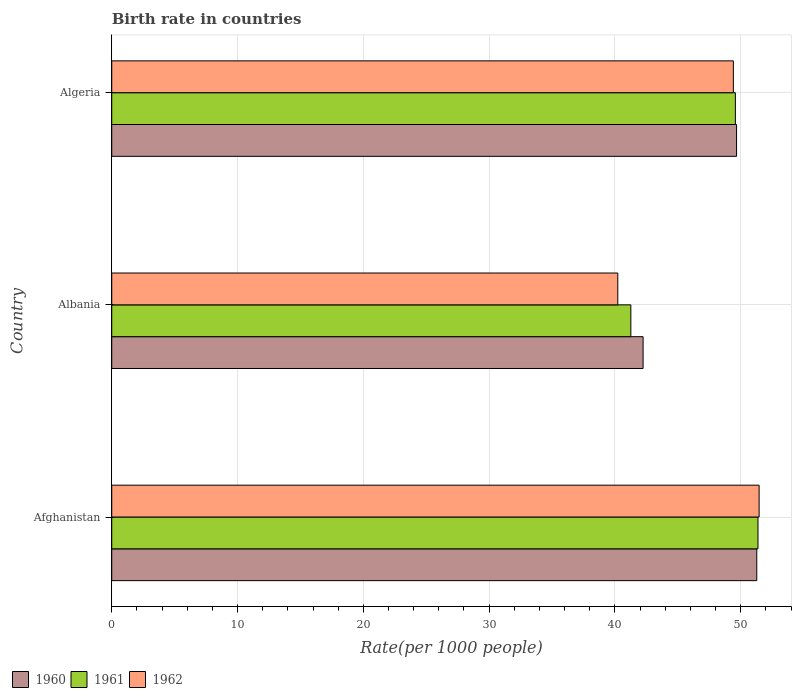How many different coloured bars are there?
Provide a succinct answer. 3. Are the number of bars per tick equal to the number of legend labels?
Offer a terse response. Yes. What is the label of the 1st group of bars from the top?
Make the answer very short. Algeria. In how many cases, is the number of bars for a given country not equal to the number of legend labels?
Your answer should be very brief. 0. What is the birth rate in 1961 in Albania?
Offer a terse response. 41.27. Across all countries, what is the maximum birth rate in 1961?
Your answer should be very brief. 51.37. Across all countries, what is the minimum birth rate in 1961?
Your answer should be compact. 41.27. In which country was the birth rate in 1962 maximum?
Give a very brief answer. Afghanistan. In which country was the birth rate in 1962 minimum?
Keep it short and to the point. Albania. What is the total birth rate in 1962 in the graph?
Your response must be concise. 141.11. What is the difference between the birth rate in 1962 in Afghanistan and that in Albania?
Ensure brevity in your answer.  11.23. What is the difference between the birth rate in 1960 in Algeria and the birth rate in 1961 in Afghanistan?
Offer a terse response. -1.7. What is the average birth rate in 1961 per country?
Ensure brevity in your answer.  47.41. What is the difference between the birth rate in 1961 and birth rate in 1962 in Algeria?
Offer a terse response. 0.16. In how many countries, is the birth rate in 1962 greater than 16 ?
Provide a short and direct response. 3. What is the ratio of the birth rate in 1960 in Albania to that in Algeria?
Your answer should be very brief. 0.85. Is the birth rate in 1962 in Afghanistan less than that in Algeria?
Your answer should be compact. No. What is the difference between the highest and the second highest birth rate in 1960?
Provide a succinct answer. 1.6. What is the difference between the highest and the lowest birth rate in 1961?
Give a very brief answer. 10.11. Is the sum of the birth rate in 1962 in Afghanistan and Algeria greater than the maximum birth rate in 1961 across all countries?
Offer a very short reply. Yes. How many bars are there?
Provide a succinct answer. 9. Are all the bars in the graph horizontal?
Ensure brevity in your answer.  Yes. How many countries are there in the graph?
Keep it short and to the point. 3. Are the values on the major ticks of X-axis written in scientific E-notation?
Make the answer very short. No. Does the graph contain grids?
Your answer should be very brief. Yes. Where does the legend appear in the graph?
Your answer should be very brief. Bottom left. How many legend labels are there?
Provide a succinct answer. 3. What is the title of the graph?
Your answer should be very brief. Birth rate in countries. What is the label or title of the X-axis?
Your response must be concise. Rate(per 1000 people). What is the label or title of the Y-axis?
Ensure brevity in your answer.  Country. What is the Rate(per 1000 people) of 1960 in Afghanistan?
Your answer should be very brief. 51.28. What is the Rate(per 1000 people) in 1961 in Afghanistan?
Give a very brief answer. 51.37. What is the Rate(per 1000 people) in 1962 in Afghanistan?
Offer a terse response. 51.46. What is the Rate(per 1000 people) in 1960 in Albania?
Your answer should be compact. 42.24. What is the Rate(per 1000 people) of 1961 in Albania?
Keep it short and to the point. 41.27. What is the Rate(per 1000 people) of 1962 in Albania?
Provide a succinct answer. 40.23. What is the Rate(per 1000 people) in 1960 in Algeria?
Give a very brief answer. 49.67. What is the Rate(per 1000 people) in 1961 in Algeria?
Your response must be concise. 49.58. What is the Rate(per 1000 people) in 1962 in Algeria?
Provide a short and direct response. 49.42. Across all countries, what is the maximum Rate(per 1000 people) in 1960?
Your response must be concise. 51.28. Across all countries, what is the maximum Rate(per 1000 people) of 1961?
Your answer should be very brief. 51.37. Across all countries, what is the maximum Rate(per 1000 people) of 1962?
Make the answer very short. 51.46. Across all countries, what is the minimum Rate(per 1000 people) in 1960?
Provide a short and direct response. 42.24. Across all countries, what is the minimum Rate(per 1000 people) of 1961?
Your answer should be very brief. 41.27. Across all countries, what is the minimum Rate(per 1000 people) in 1962?
Keep it short and to the point. 40.23. What is the total Rate(per 1000 people) of 1960 in the graph?
Your response must be concise. 143.19. What is the total Rate(per 1000 people) of 1961 in the graph?
Provide a short and direct response. 142.22. What is the total Rate(per 1000 people) in 1962 in the graph?
Provide a short and direct response. 141.11. What is the difference between the Rate(per 1000 people) in 1960 in Afghanistan and that in Albania?
Provide a succinct answer. 9.04. What is the difference between the Rate(per 1000 people) of 1961 in Afghanistan and that in Albania?
Give a very brief answer. 10.11. What is the difference between the Rate(per 1000 people) of 1962 in Afghanistan and that in Albania?
Make the answer very short. 11.23. What is the difference between the Rate(per 1000 people) of 1960 in Afghanistan and that in Algeria?
Your answer should be very brief. 1.6. What is the difference between the Rate(per 1000 people) of 1961 in Afghanistan and that in Algeria?
Give a very brief answer. 1.8. What is the difference between the Rate(per 1000 people) in 1962 in Afghanistan and that in Algeria?
Offer a terse response. 2.05. What is the difference between the Rate(per 1000 people) in 1960 in Albania and that in Algeria?
Your response must be concise. -7.43. What is the difference between the Rate(per 1000 people) in 1961 in Albania and that in Algeria?
Ensure brevity in your answer.  -8.31. What is the difference between the Rate(per 1000 people) of 1962 in Albania and that in Algeria?
Provide a succinct answer. -9.19. What is the difference between the Rate(per 1000 people) of 1960 in Afghanistan and the Rate(per 1000 people) of 1961 in Albania?
Offer a very short reply. 10.01. What is the difference between the Rate(per 1000 people) in 1960 in Afghanistan and the Rate(per 1000 people) in 1962 in Albania?
Make the answer very short. 11.05. What is the difference between the Rate(per 1000 people) of 1961 in Afghanistan and the Rate(per 1000 people) of 1962 in Albania?
Ensure brevity in your answer.  11.14. What is the difference between the Rate(per 1000 people) of 1960 in Afghanistan and the Rate(per 1000 people) of 1962 in Algeria?
Make the answer very short. 1.86. What is the difference between the Rate(per 1000 people) in 1961 in Afghanistan and the Rate(per 1000 people) in 1962 in Algeria?
Your response must be concise. 1.96. What is the difference between the Rate(per 1000 people) of 1960 in Albania and the Rate(per 1000 people) of 1961 in Algeria?
Your answer should be compact. -7.34. What is the difference between the Rate(per 1000 people) in 1960 in Albania and the Rate(per 1000 people) in 1962 in Algeria?
Your answer should be compact. -7.18. What is the difference between the Rate(per 1000 people) in 1961 in Albania and the Rate(per 1000 people) in 1962 in Algeria?
Give a very brief answer. -8.15. What is the average Rate(per 1000 people) in 1960 per country?
Offer a very short reply. 47.73. What is the average Rate(per 1000 people) of 1961 per country?
Your answer should be very brief. 47.41. What is the average Rate(per 1000 people) of 1962 per country?
Give a very brief answer. 47.04. What is the difference between the Rate(per 1000 people) in 1960 and Rate(per 1000 people) in 1961 in Afghanistan?
Provide a short and direct response. -0.1. What is the difference between the Rate(per 1000 people) of 1960 and Rate(per 1000 people) of 1962 in Afghanistan?
Provide a succinct answer. -0.19. What is the difference between the Rate(per 1000 people) in 1961 and Rate(per 1000 people) in 1962 in Afghanistan?
Offer a very short reply. -0.09. What is the difference between the Rate(per 1000 people) of 1960 and Rate(per 1000 people) of 1961 in Albania?
Your answer should be compact. 0.97. What is the difference between the Rate(per 1000 people) of 1960 and Rate(per 1000 people) of 1962 in Albania?
Keep it short and to the point. 2.01. What is the difference between the Rate(per 1000 people) in 1961 and Rate(per 1000 people) in 1962 in Albania?
Make the answer very short. 1.04. What is the difference between the Rate(per 1000 people) of 1960 and Rate(per 1000 people) of 1961 in Algeria?
Ensure brevity in your answer.  0.1. What is the difference between the Rate(per 1000 people) of 1960 and Rate(per 1000 people) of 1962 in Algeria?
Keep it short and to the point. 0.26. What is the difference between the Rate(per 1000 people) of 1961 and Rate(per 1000 people) of 1962 in Algeria?
Offer a terse response. 0.16. What is the ratio of the Rate(per 1000 people) in 1960 in Afghanistan to that in Albania?
Provide a short and direct response. 1.21. What is the ratio of the Rate(per 1000 people) in 1961 in Afghanistan to that in Albania?
Ensure brevity in your answer.  1.24. What is the ratio of the Rate(per 1000 people) in 1962 in Afghanistan to that in Albania?
Offer a terse response. 1.28. What is the ratio of the Rate(per 1000 people) of 1960 in Afghanistan to that in Algeria?
Your answer should be very brief. 1.03. What is the ratio of the Rate(per 1000 people) of 1961 in Afghanistan to that in Algeria?
Your response must be concise. 1.04. What is the ratio of the Rate(per 1000 people) in 1962 in Afghanistan to that in Algeria?
Your answer should be compact. 1.04. What is the ratio of the Rate(per 1000 people) in 1960 in Albania to that in Algeria?
Offer a very short reply. 0.85. What is the ratio of the Rate(per 1000 people) in 1961 in Albania to that in Algeria?
Provide a short and direct response. 0.83. What is the ratio of the Rate(per 1000 people) in 1962 in Albania to that in Algeria?
Provide a short and direct response. 0.81. What is the difference between the highest and the second highest Rate(per 1000 people) in 1960?
Keep it short and to the point. 1.6. What is the difference between the highest and the second highest Rate(per 1000 people) in 1961?
Provide a succinct answer. 1.8. What is the difference between the highest and the second highest Rate(per 1000 people) of 1962?
Provide a short and direct response. 2.05. What is the difference between the highest and the lowest Rate(per 1000 people) of 1960?
Your response must be concise. 9.04. What is the difference between the highest and the lowest Rate(per 1000 people) of 1961?
Give a very brief answer. 10.11. What is the difference between the highest and the lowest Rate(per 1000 people) of 1962?
Make the answer very short. 11.23. 